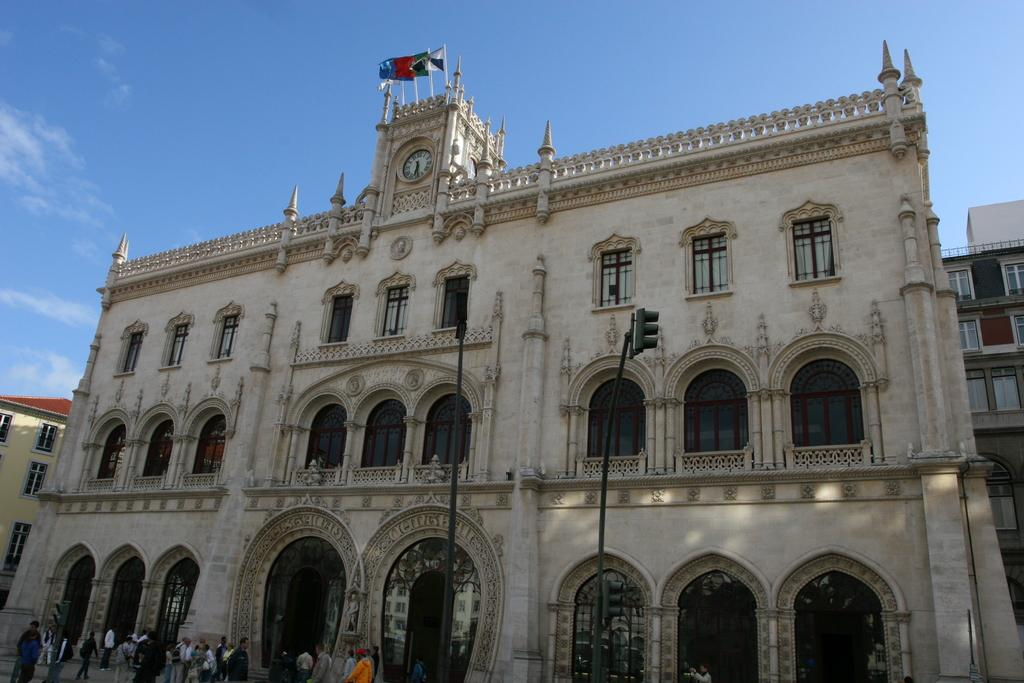What is located in the center of the image? In the center of the image, there are buildings, a wall, a wall clock, windows, flags, a fence, poles, and a group of people. Can you describe the wall clock in the image? The wall clock is present in the center of the image. What can be seen in the background of the image? The sky and clouds are visible in the background of the image. What type of soup is being served in the image? There is no soup present in the image. How many birds are perched on the poles in the image? There are no birds present in the image. 